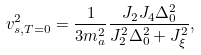<formula> <loc_0><loc_0><loc_500><loc_500>v _ { s , T = 0 } ^ { 2 } = \frac { 1 } { 3 m _ { a } ^ { 2 } } \frac { J _ { 2 } J _ { 4 } \Delta _ { 0 } ^ { 2 } } { J _ { 2 } ^ { 2 } \Delta _ { 0 } ^ { 2 } + J _ { \xi } ^ { 2 } } ,</formula> 